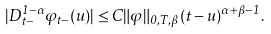Convert formula to latex. <formula><loc_0><loc_0><loc_500><loc_500>| D _ { t - } ^ { 1 - \alpha } \varphi _ { t - } ( u ) | \leq C \| \varphi \| _ { 0 , T , \beta } ( t - u ) ^ { \alpha + \beta - 1 } .</formula> 